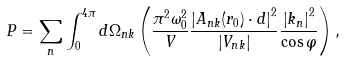Convert formula to latex. <formula><loc_0><loc_0><loc_500><loc_500>P = \sum _ { n } \int _ { 0 } ^ { 4 \pi } d \Omega _ { n k } \left ( \frac { \pi ^ { 2 } \omega _ { 0 } ^ { 2 } } { V } \frac { \left | A _ { n k } ( r _ { 0 } ) \cdot d \right | ^ { 2 } } { \left | V _ { n k } \right | } \frac { \left | k _ { n } \right | ^ { 2 } } { \cos \varphi } \right ) ,</formula> 